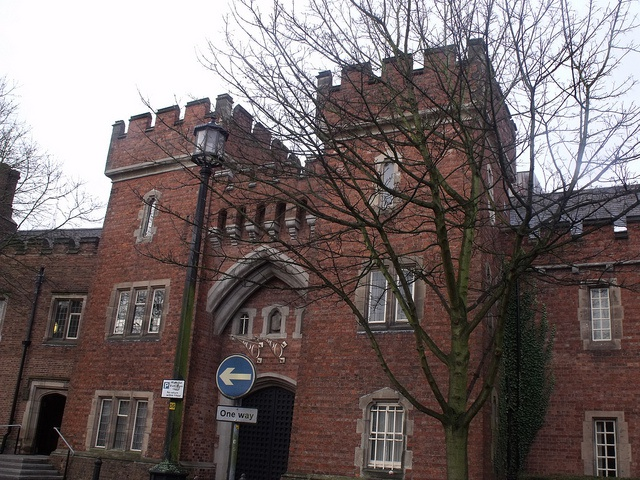Describe the objects in this image and their specific colors. I can see various objects in this image with different colors. 